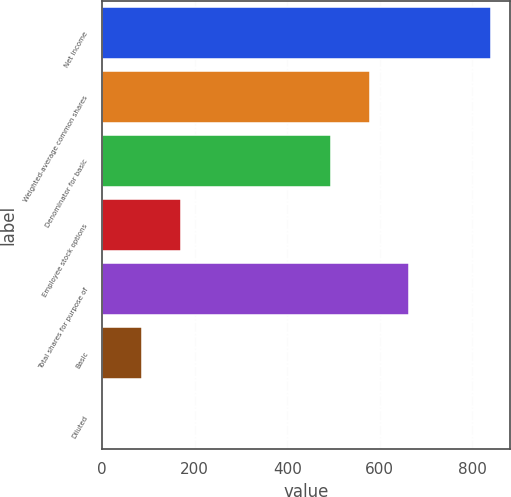Convert chart to OTSL. <chart><loc_0><loc_0><loc_500><loc_500><bar_chart><fcel>Net income<fcel>Weighted-average common shares<fcel>Denominator for basic<fcel>Employee stock options<fcel>Total shares for purpose of<fcel>Basic<fcel>Diluted<nl><fcel>840<fcel>578.84<fcel>495<fcel>169.28<fcel>662.68<fcel>85.44<fcel>1.6<nl></chart> 